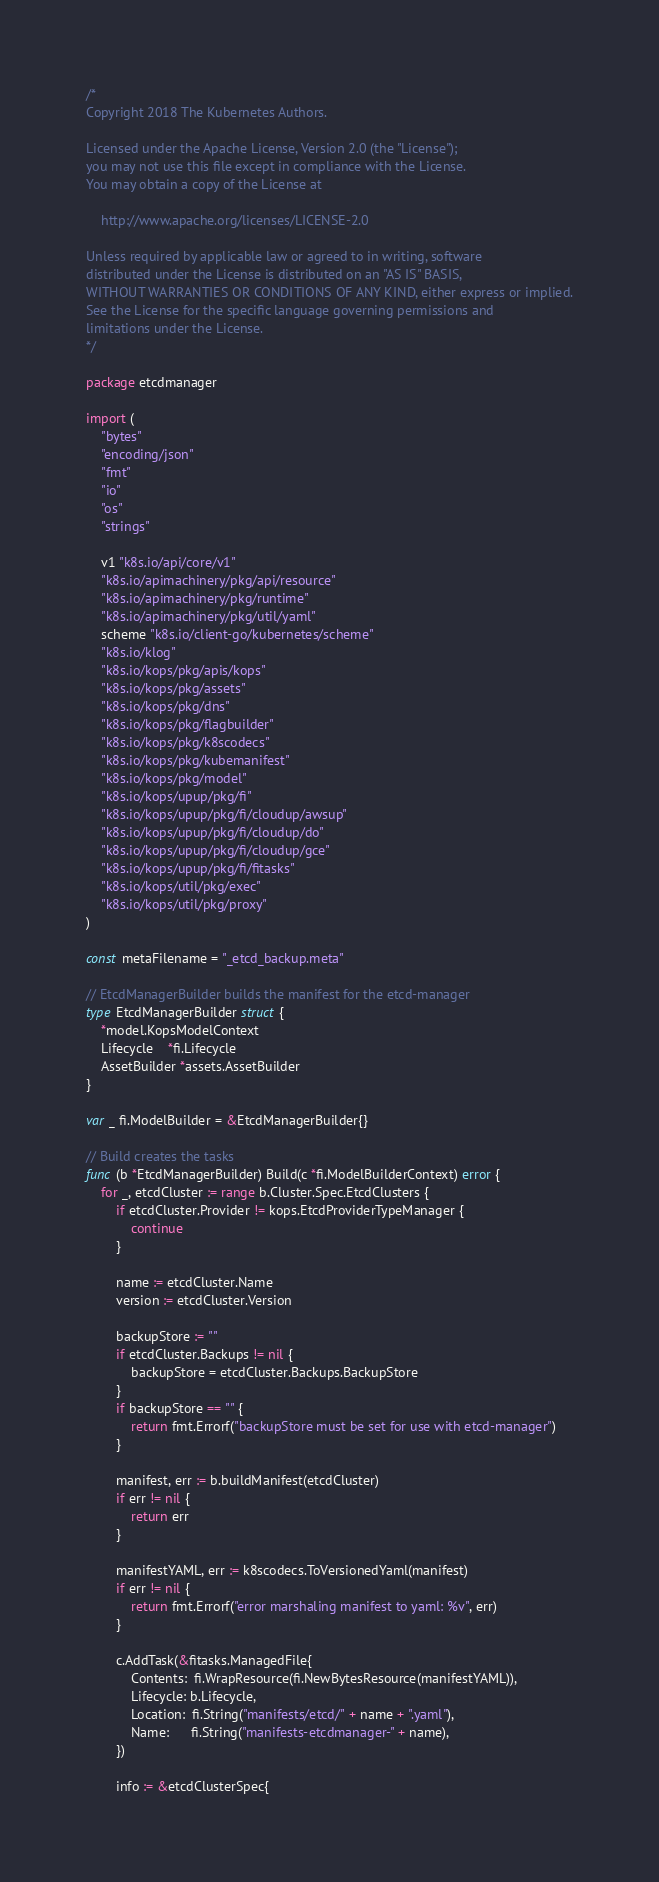<code> <loc_0><loc_0><loc_500><loc_500><_Go_>/*
Copyright 2018 The Kubernetes Authors.

Licensed under the Apache License, Version 2.0 (the "License");
you may not use this file except in compliance with the License.
You may obtain a copy of the License at

    http://www.apache.org/licenses/LICENSE-2.0

Unless required by applicable law or agreed to in writing, software
distributed under the License is distributed on an "AS IS" BASIS,
WITHOUT WARRANTIES OR CONDITIONS OF ANY KIND, either express or implied.
See the License for the specific language governing permissions and
limitations under the License.
*/

package etcdmanager

import (
	"bytes"
	"encoding/json"
	"fmt"
	"io"
	"os"
	"strings"

	v1 "k8s.io/api/core/v1"
	"k8s.io/apimachinery/pkg/api/resource"
	"k8s.io/apimachinery/pkg/runtime"
	"k8s.io/apimachinery/pkg/util/yaml"
	scheme "k8s.io/client-go/kubernetes/scheme"
	"k8s.io/klog"
	"k8s.io/kops/pkg/apis/kops"
	"k8s.io/kops/pkg/assets"
	"k8s.io/kops/pkg/dns"
	"k8s.io/kops/pkg/flagbuilder"
	"k8s.io/kops/pkg/k8scodecs"
	"k8s.io/kops/pkg/kubemanifest"
	"k8s.io/kops/pkg/model"
	"k8s.io/kops/upup/pkg/fi"
	"k8s.io/kops/upup/pkg/fi/cloudup/awsup"
	"k8s.io/kops/upup/pkg/fi/cloudup/do"
	"k8s.io/kops/upup/pkg/fi/cloudup/gce"
	"k8s.io/kops/upup/pkg/fi/fitasks"
	"k8s.io/kops/util/pkg/exec"
	"k8s.io/kops/util/pkg/proxy"
)

const metaFilename = "_etcd_backup.meta"

// EtcdManagerBuilder builds the manifest for the etcd-manager
type EtcdManagerBuilder struct {
	*model.KopsModelContext
	Lifecycle    *fi.Lifecycle
	AssetBuilder *assets.AssetBuilder
}

var _ fi.ModelBuilder = &EtcdManagerBuilder{}

// Build creates the tasks
func (b *EtcdManagerBuilder) Build(c *fi.ModelBuilderContext) error {
	for _, etcdCluster := range b.Cluster.Spec.EtcdClusters {
		if etcdCluster.Provider != kops.EtcdProviderTypeManager {
			continue
		}

		name := etcdCluster.Name
		version := etcdCluster.Version

		backupStore := ""
		if etcdCluster.Backups != nil {
			backupStore = etcdCluster.Backups.BackupStore
		}
		if backupStore == "" {
			return fmt.Errorf("backupStore must be set for use with etcd-manager")
		}

		manifest, err := b.buildManifest(etcdCluster)
		if err != nil {
			return err
		}

		manifestYAML, err := k8scodecs.ToVersionedYaml(manifest)
		if err != nil {
			return fmt.Errorf("error marshaling manifest to yaml: %v", err)
		}

		c.AddTask(&fitasks.ManagedFile{
			Contents:  fi.WrapResource(fi.NewBytesResource(manifestYAML)),
			Lifecycle: b.Lifecycle,
			Location:  fi.String("manifests/etcd/" + name + ".yaml"),
			Name:      fi.String("manifests-etcdmanager-" + name),
		})

		info := &etcdClusterSpec{</code> 